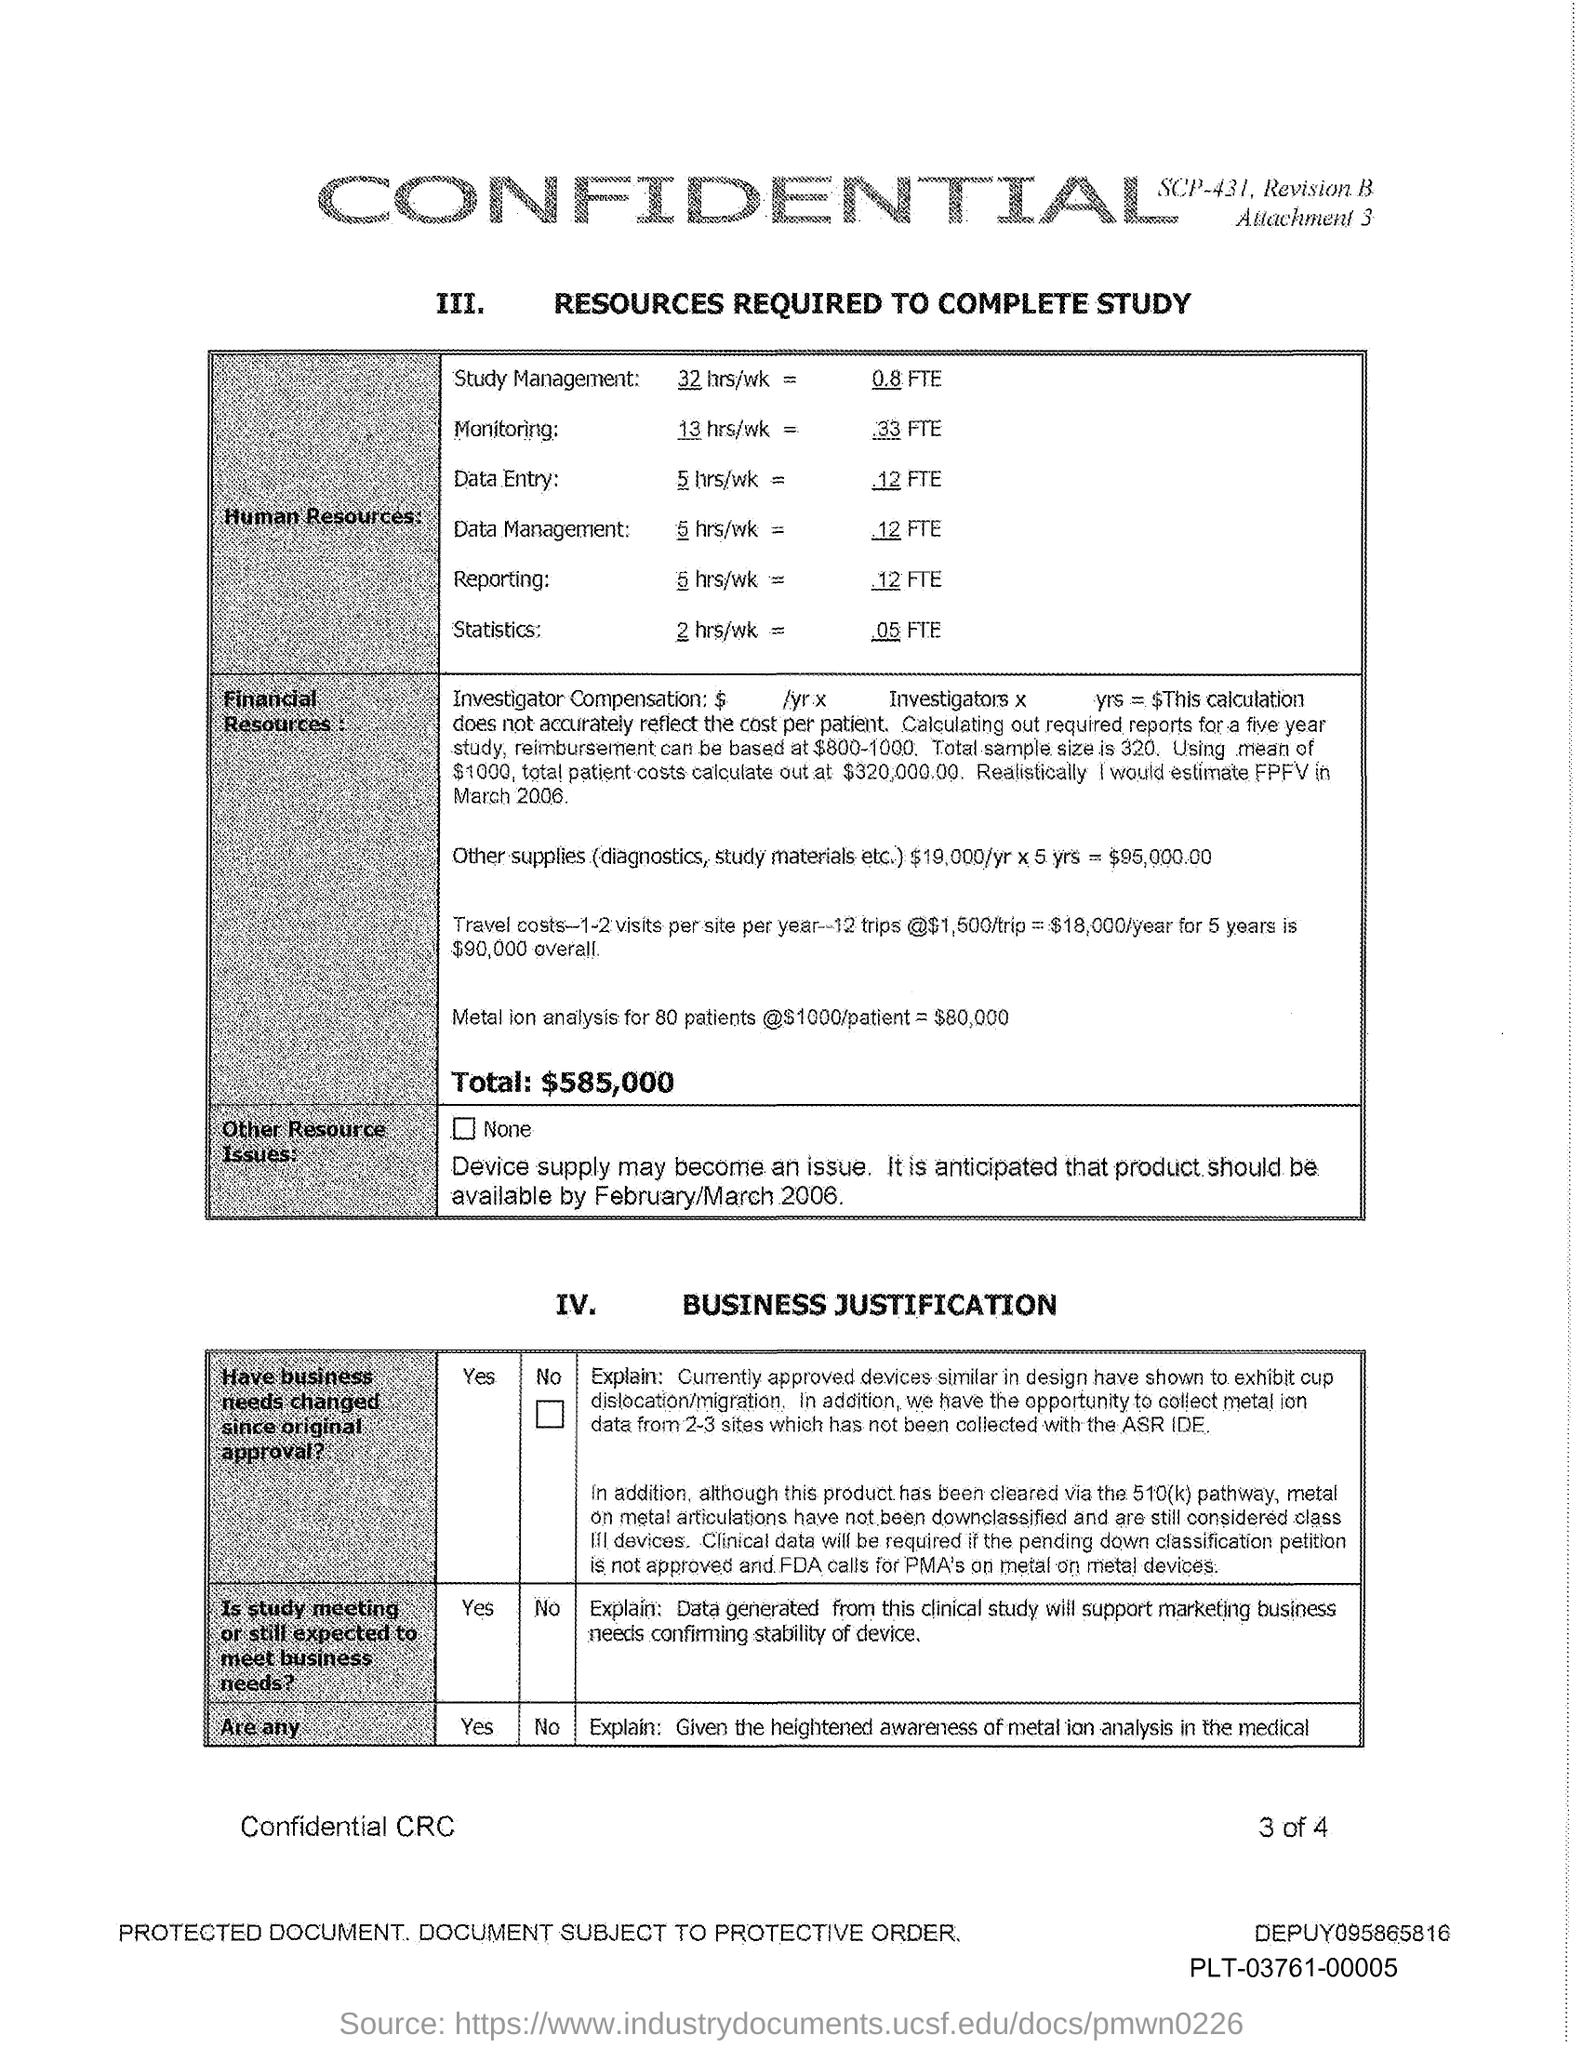What is the heading of table with roman number iv ?
Provide a short and direct response. BUSINESS JUSTIFICATION. How many hours per week is required for monitoring?
Make the answer very short. 13 HRS/WK. 